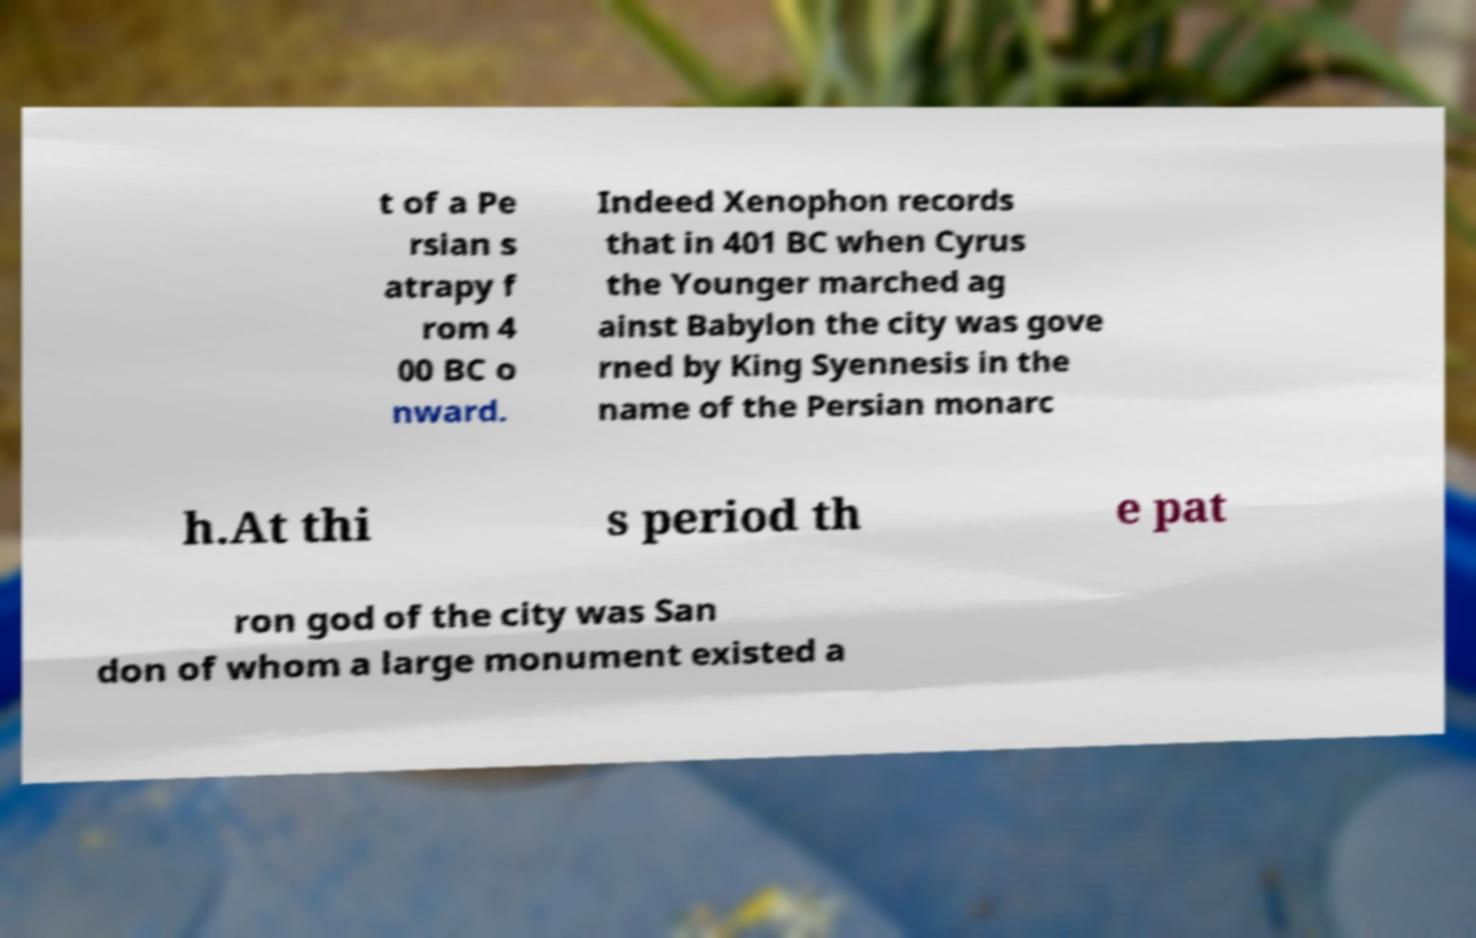Can you read and provide the text displayed in the image?This photo seems to have some interesting text. Can you extract and type it out for me? t of a Pe rsian s atrapy f rom 4 00 BC o nward. Indeed Xenophon records that in 401 BC when Cyrus the Younger marched ag ainst Babylon the city was gove rned by King Syennesis in the name of the Persian monarc h.At thi s period th e pat ron god of the city was San don of whom a large monument existed a 